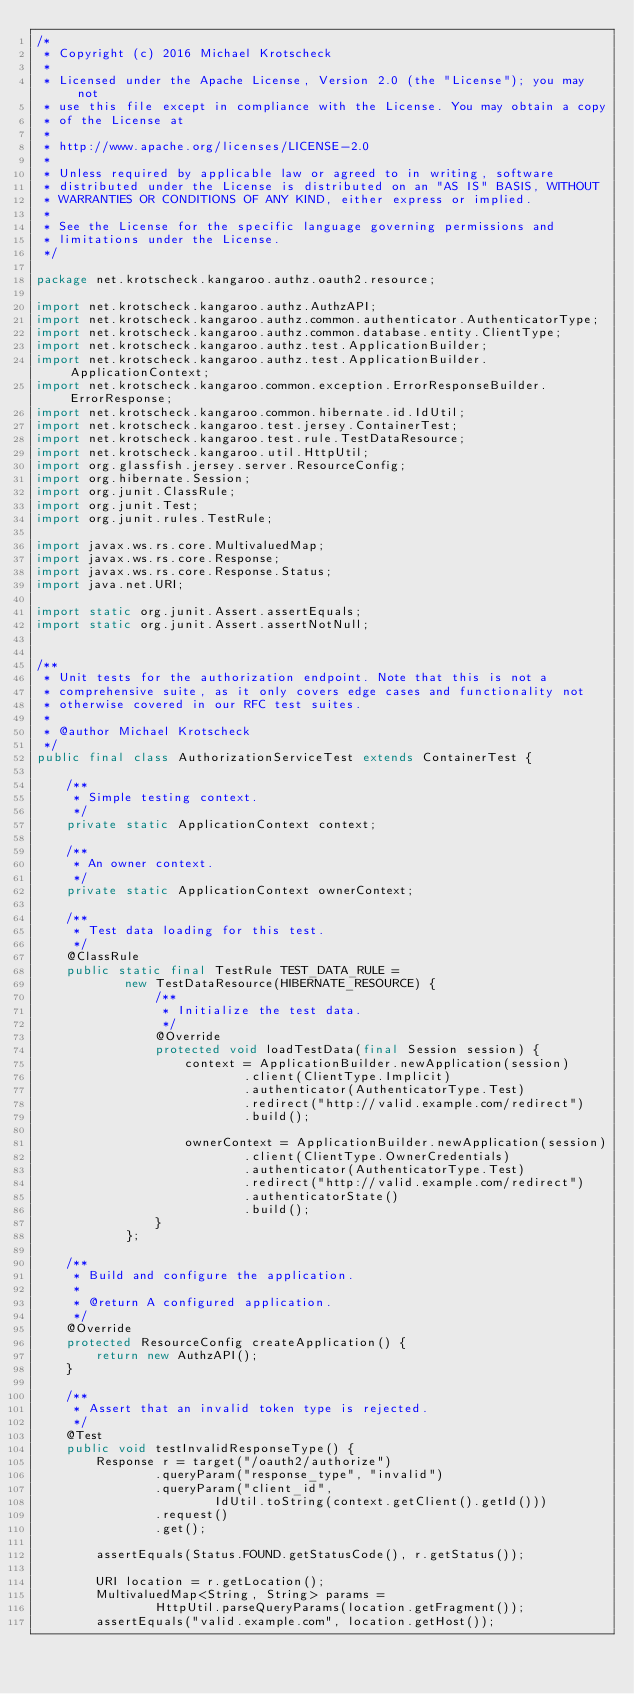Convert code to text. <code><loc_0><loc_0><loc_500><loc_500><_Java_>/*
 * Copyright (c) 2016 Michael Krotscheck
 *
 * Licensed under the Apache License, Version 2.0 (the "License"); you may not
 * use this file except in compliance with the License. You may obtain a copy
 * of the License at
 *
 * http://www.apache.org/licenses/LICENSE-2.0
 *
 * Unless required by applicable law or agreed to in writing, software
 * distributed under the License is distributed on an "AS IS" BASIS, WITHOUT
 * WARRANTIES OR CONDITIONS OF ANY KIND, either express or implied.
 *
 * See the License for the specific language governing permissions and
 * limitations under the License.
 */

package net.krotscheck.kangaroo.authz.oauth2.resource;

import net.krotscheck.kangaroo.authz.AuthzAPI;
import net.krotscheck.kangaroo.authz.common.authenticator.AuthenticatorType;
import net.krotscheck.kangaroo.authz.common.database.entity.ClientType;
import net.krotscheck.kangaroo.authz.test.ApplicationBuilder;
import net.krotscheck.kangaroo.authz.test.ApplicationBuilder.ApplicationContext;
import net.krotscheck.kangaroo.common.exception.ErrorResponseBuilder.ErrorResponse;
import net.krotscheck.kangaroo.common.hibernate.id.IdUtil;
import net.krotscheck.kangaroo.test.jersey.ContainerTest;
import net.krotscheck.kangaroo.test.rule.TestDataResource;
import net.krotscheck.kangaroo.util.HttpUtil;
import org.glassfish.jersey.server.ResourceConfig;
import org.hibernate.Session;
import org.junit.ClassRule;
import org.junit.Test;
import org.junit.rules.TestRule;

import javax.ws.rs.core.MultivaluedMap;
import javax.ws.rs.core.Response;
import javax.ws.rs.core.Response.Status;
import java.net.URI;

import static org.junit.Assert.assertEquals;
import static org.junit.Assert.assertNotNull;


/**
 * Unit tests for the authorization endpoint. Note that this is not a
 * comprehensive suite, as it only covers edge cases and functionality not
 * otherwise covered in our RFC test suites.
 *
 * @author Michael Krotscheck
 */
public final class AuthorizationServiceTest extends ContainerTest {

    /**
     * Simple testing context.
     */
    private static ApplicationContext context;

    /**
     * An owner context.
     */
    private static ApplicationContext ownerContext;

    /**
     * Test data loading for this test.
     */
    @ClassRule
    public static final TestRule TEST_DATA_RULE =
            new TestDataResource(HIBERNATE_RESOURCE) {
                /**
                 * Initialize the test data.
                 */
                @Override
                protected void loadTestData(final Session session) {
                    context = ApplicationBuilder.newApplication(session)
                            .client(ClientType.Implicit)
                            .authenticator(AuthenticatorType.Test)
                            .redirect("http://valid.example.com/redirect")
                            .build();

                    ownerContext = ApplicationBuilder.newApplication(session)
                            .client(ClientType.OwnerCredentials)
                            .authenticator(AuthenticatorType.Test)
                            .redirect("http://valid.example.com/redirect")
                            .authenticatorState()
                            .build();
                }
            };

    /**
     * Build and configure the application.
     *
     * @return A configured application.
     */
    @Override
    protected ResourceConfig createApplication() {
        return new AuthzAPI();
    }

    /**
     * Assert that an invalid token type is rejected.
     */
    @Test
    public void testInvalidResponseType() {
        Response r = target("/oauth2/authorize")
                .queryParam("response_type", "invalid")
                .queryParam("client_id",
                        IdUtil.toString(context.getClient().getId()))
                .request()
                .get();

        assertEquals(Status.FOUND.getStatusCode(), r.getStatus());

        URI location = r.getLocation();
        MultivaluedMap<String, String> params =
                HttpUtil.parseQueryParams(location.getFragment());
        assertEquals("valid.example.com", location.getHost());</code> 